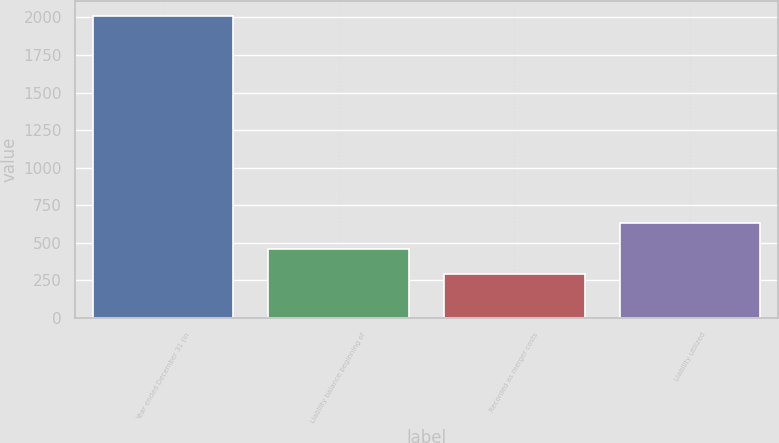Convert chart. <chart><loc_0><loc_0><loc_500><loc_500><bar_chart><fcel>Year ended December 31 (in<fcel>Liability balance beginning of<fcel>Recorded as merger costs<fcel>Liability utilized<nl><fcel>2006<fcel>461.6<fcel>290<fcel>633.2<nl></chart> 